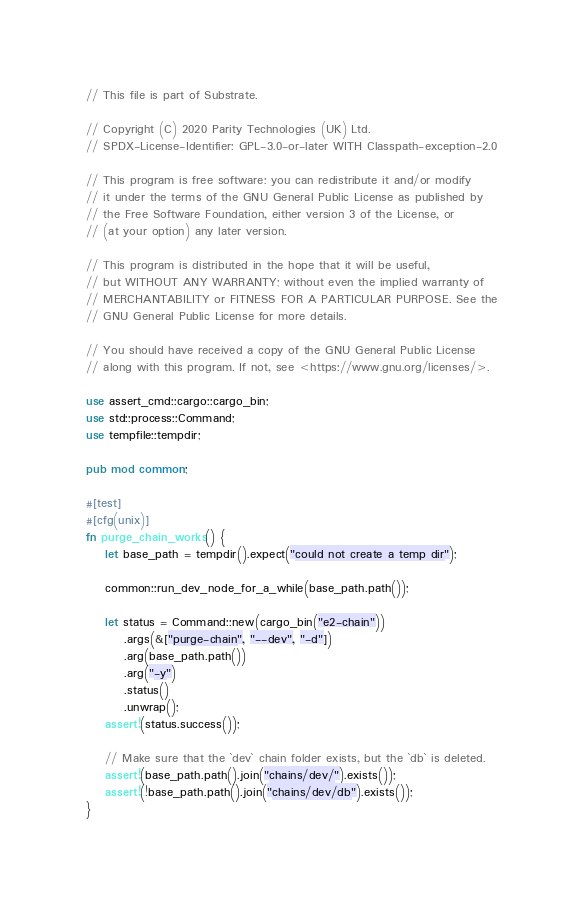<code> <loc_0><loc_0><loc_500><loc_500><_Rust_>// This file is part of Substrate.

// Copyright (C) 2020 Parity Technologies (UK) Ltd.
// SPDX-License-Identifier: GPL-3.0-or-later WITH Classpath-exception-2.0

// This program is free software: you can redistribute it and/or modify
// it under the terms of the GNU General Public License as published by
// the Free Software Foundation, either version 3 of the License, or
// (at your option) any later version.

// This program is distributed in the hope that it will be useful,
// but WITHOUT ANY WARRANTY; without even the implied warranty of
// MERCHANTABILITY or FITNESS FOR A PARTICULAR PURPOSE. See the
// GNU General Public License for more details.

// You should have received a copy of the GNU General Public License
// along with this program. If not, see <https://www.gnu.org/licenses/>.

use assert_cmd::cargo::cargo_bin;
use std::process::Command;
use tempfile::tempdir;

pub mod common;

#[test]
#[cfg(unix)]
fn purge_chain_works() {
    let base_path = tempdir().expect("could not create a temp dir");

    common::run_dev_node_for_a_while(base_path.path());

    let status = Command::new(cargo_bin("e2-chain"))
        .args(&["purge-chain", "--dev", "-d"])
        .arg(base_path.path())
        .arg("-y")
        .status()
        .unwrap();
    assert!(status.success());

    // Make sure that the `dev` chain folder exists, but the `db` is deleted.
    assert!(base_path.path().join("chains/dev/").exists());
    assert!(!base_path.path().join("chains/dev/db").exists());
}
</code> 